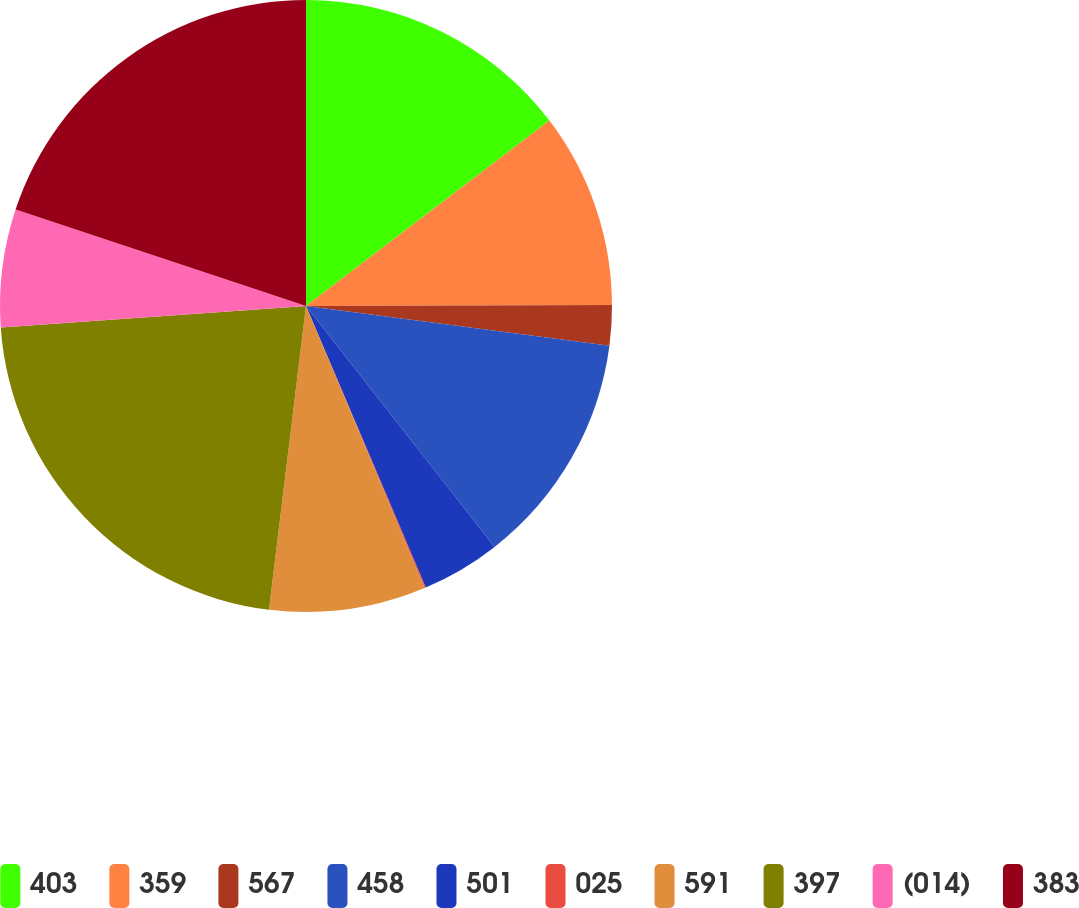Convert chart. <chart><loc_0><loc_0><loc_500><loc_500><pie_chart><fcel>403<fcel>359<fcel>567<fcel>458<fcel>501<fcel>025<fcel>591<fcel>397<fcel>(014)<fcel>383<nl><fcel>14.64%<fcel>10.31%<fcel>2.12%<fcel>12.36%<fcel>4.17%<fcel>0.07%<fcel>8.26%<fcel>21.95%<fcel>6.22%<fcel>19.9%<nl></chart> 